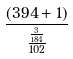<formula> <loc_0><loc_0><loc_500><loc_500>\frac { ( 3 9 4 + 1 ) } { \frac { \frac { 3 } { 1 8 4 } } { 1 0 2 } }</formula> 